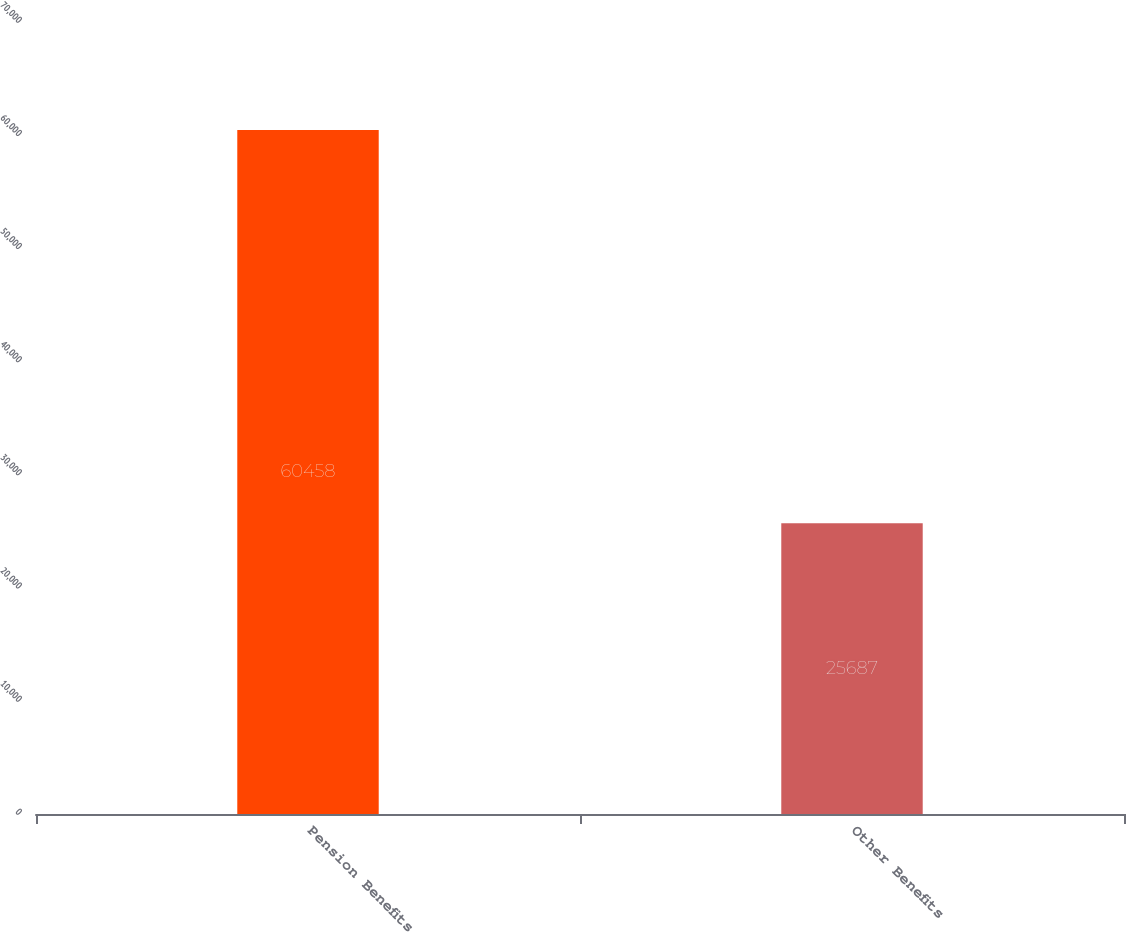<chart> <loc_0><loc_0><loc_500><loc_500><bar_chart><fcel>Pension Benefits<fcel>Other Benefits<nl><fcel>60458<fcel>25687<nl></chart> 